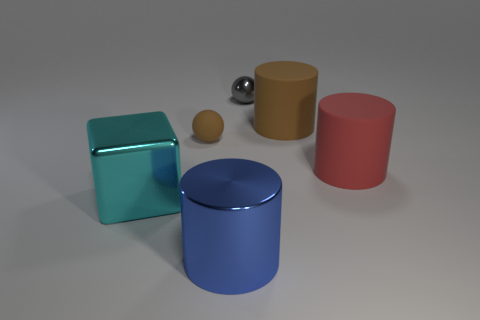Is there a rubber cylinder that has the same size as the metallic block?
Provide a succinct answer. Yes. Is the number of blue objects on the right side of the tiny gray sphere less than the number of big green cylinders?
Offer a terse response. No. Does the gray object have the same size as the brown ball?
Your answer should be very brief. Yes. There is another brown object that is the same material as the large brown object; what is its size?
Offer a terse response. Small. What number of other spheres have the same color as the tiny rubber sphere?
Your answer should be very brief. 0. Is the number of red cylinders that are on the left side of the large cyan metal object less than the number of brown matte objects that are to the left of the gray ball?
Provide a succinct answer. Yes. There is a small object behind the big brown object; does it have the same shape as the small brown object?
Offer a terse response. Yes. Do the ball left of the small gray shiny object and the big red object have the same material?
Give a very brief answer. Yes. There is a tiny thing that is in front of the brown object to the right of the small object that is to the right of the tiny matte object; what is it made of?
Provide a short and direct response. Rubber. What number of other objects are there of the same shape as the tiny gray object?
Make the answer very short. 1. 